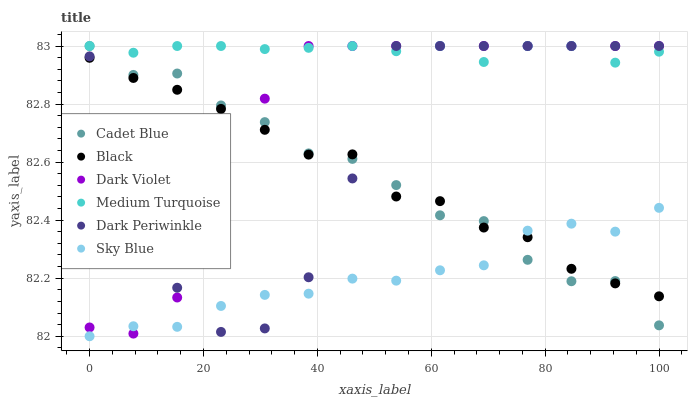Does Sky Blue have the minimum area under the curve?
Answer yes or no. Yes. Does Medium Turquoise have the maximum area under the curve?
Answer yes or no. Yes. Does Dark Violet have the minimum area under the curve?
Answer yes or no. No. Does Dark Violet have the maximum area under the curve?
Answer yes or no. No. Is Medium Turquoise the smoothest?
Answer yes or no. Yes. Is Dark Periwinkle the roughest?
Answer yes or no. Yes. Is Dark Violet the smoothest?
Answer yes or no. No. Is Dark Violet the roughest?
Answer yes or no. No. Does Sky Blue have the lowest value?
Answer yes or no. Yes. Does Dark Violet have the lowest value?
Answer yes or no. No. Does Dark Periwinkle have the highest value?
Answer yes or no. Yes. Does Black have the highest value?
Answer yes or no. No. Is Sky Blue less than Medium Turquoise?
Answer yes or no. Yes. Is Medium Turquoise greater than Sky Blue?
Answer yes or no. Yes. Does Dark Violet intersect Sky Blue?
Answer yes or no. Yes. Is Dark Violet less than Sky Blue?
Answer yes or no. No. Is Dark Violet greater than Sky Blue?
Answer yes or no. No. Does Sky Blue intersect Medium Turquoise?
Answer yes or no. No. 